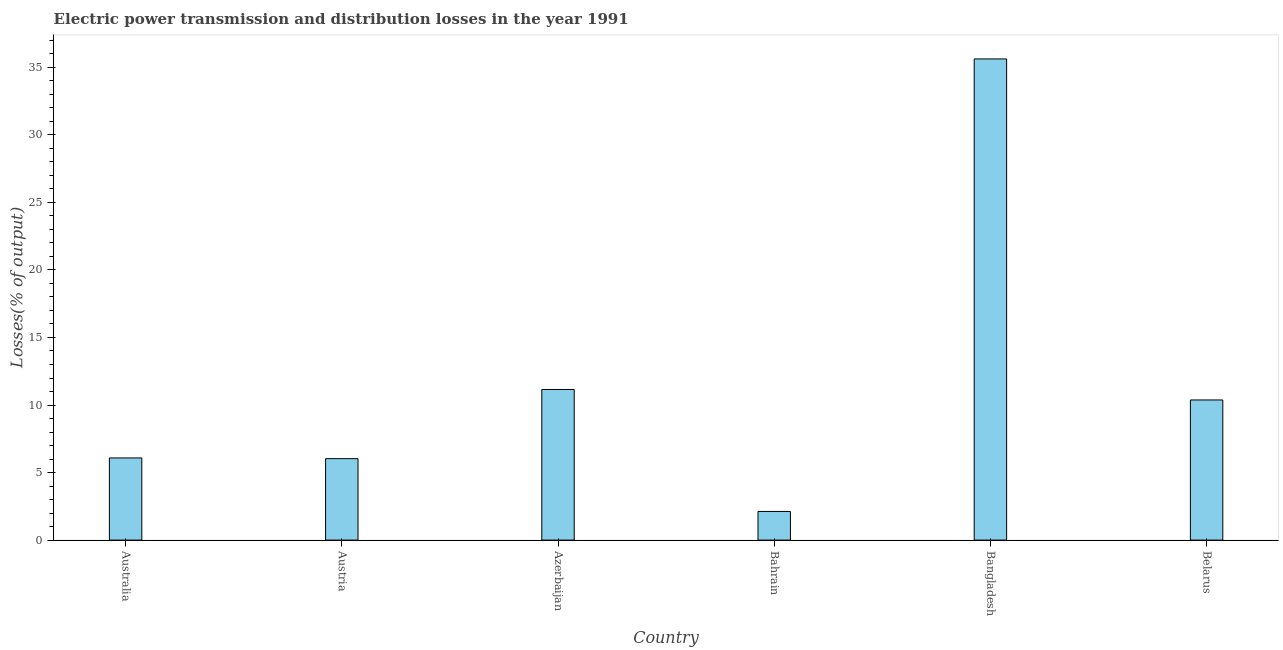What is the title of the graph?
Offer a terse response. Electric power transmission and distribution losses in the year 1991. What is the label or title of the Y-axis?
Ensure brevity in your answer.  Losses(% of output). What is the electric power transmission and distribution losses in Bahrain?
Make the answer very short. 2.12. Across all countries, what is the maximum electric power transmission and distribution losses?
Offer a very short reply. 35.62. Across all countries, what is the minimum electric power transmission and distribution losses?
Your answer should be compact. 2.12. In which country was the electric power transmission and distribution losses maximum?
Your answer should be very brief. Bangladesh. In which country was the electric power transmission and distribution losses minimum?
Provide a short and direct response. Bahrain. What is the sum of the electric power transmission and distribution losses?
Offer a terse response. 71.38. What is the difference between the electric power transmission and distribution losses in Austria and Bahrain?
Offer a terse response. 3.91. What is the average electric power transmission and distribution losses per country?
Your answer should be compact. 11.9. What is the median electric power transmission and distribution losses?
Provide a succinct answer. 8.23. In how many countries, is the electric power transmission and distribution losses greater than 28 %?
Your response must be concise. 1. What is the ratio of the electric power transmission and distribution losses in Austria to that in Bahrain?
Your answer should be very brief. 2.84. What is the difference between the highest and the second highest electric power transmission and distribution losses?
Keep it short and to the point. 24.47. Is the sum of the electric power transmission and distribution losses in Australia and Azerbaijan greater than the maximum electric power transmission and distribution losses across all countries?
Your answer should be compact. No. What is the difference between the highest and the lowest electric power transmission and distribution losses?
Your answer should be compact. 33.5. In how many countries, is the electric power transmission and distribution losses greater than the average electric power transmission and distribution losses taken over all countries?
Your response must be concise. 1. How many bars are there?
Make the answer very short. 6. How many countries are there in the graph?
Your response must be concise. 6. What is the difference between two consecutive major ticks on the Y-axis?
Provide a succinct answer. 5. Are the values on the major ticks of Y-axis written in scientific E-notation?
Ensure brevity in your answer.  No. What is the Losses(% of output) in Australia?
Provide a succinct answer. 6.08. What is the Losses(% of output) of Austria?
Make the answer very short. 6.03. What is the Losses(% of output) of Azerbaijan?
Ensure brevity in your answer.  11.15. What is the Losses(% of output) of Bahrain?
Your answer should be very brief. 2.12. What is the Losses(% of output) of Bangladesh?
Keep it short and to the point. 35.62. What is the Losses(% of output) in Belarus?
Keep it short and to the point. 10.38. What is the difference between the Losses(% of output) in Australia and Austria?
Your answer should be very brief. 0.05. What is the difference between the Losses(% of output) in Australia and Azerbaijan?
Your answer should be very brief. -5.07. What is the difference between the Losses(% of output) in Australia and Bahrain?
Give a very brief answer. 3.96. What is the difference between the Losses(% of output) in Australia and Bangladesh?
Your answer should be compact. -29.54. What is the difference between the Losses(% of output) in Australia and Belarus?
Keep it short and to the point. -4.29. What is the difference between the Losses(% of output) in Austria and Azerbaijan?
Make the answer very short. -5.12. What is the difference between the Losses(% of output) in Austria and Bahrain?
Provide a succinct answer. 3.91. What is the difference between the Losses(% of output) in Austria and Bangladesh?
Your answer should be very brief. -29.59. What is the difference between the Losses(% of output) in Austria and Belarus?
Your response must be concise. -4.35. What is the difference between the Losses(% of output) in Azerbaijan and Bahrain?
Your response must be concise. 9.03. What is the difference between the Losses(% of output) in Azerbaijan and Bangladesh?
Your answer should be compact. -24.47. What is the difference between the Losses(% of output) in Azerbaijan and Belarus?
Keep it short and to the point. 0.78. What is the difference between the Losses(% of output) in Bahrain and Bangladesh?
Your answer should be very brief. -33.5. What is the difference between the Losses(% of output) in Bahrain and Belarus?
Give a very brief answer. -8.25. What is the difference between the Losses(% of output) in Bangladesh and Belarus?
Your answer should be very brief. 25.25. What is the ratio of the Losses(% of output) in Australia to that in Azerbaijan?
Provide a succinct answer. 0.55. What is the ratio of the Losses(% of output) in Australia to that in Bahrain?
Provide a succinct answer. 2.87. What is the ratio of the Losses(% of output) in Australia to that in Bangladesh?
Provide a succinct answer. 0.17. What is the ratio of the Losses(% of output) in Australia to that in Belarus?
Your response must be concise. 0.59. What is the ratio of the Losses(% of output) in Austria to that in Azerbaijan?
Keep it short and to the point. 0.54. What is the ratio of the Losses(% of output) in Austria to that in Bahrain?
Keep it short and to the point. 2.84. What is the ratio of the Losses(% of output) in Austria to that in Bangladesh?
Ensure brevity in your answer.  0.17. What is the ratio of the Losses(% of output) in Austria to that in Belarus?
Your answer should be compact. 0.58. What is the ratio of the Losses(% of output) in Azerbaijan to that in Bahrain?
Give a very brief answer. 5.26. What is the ratio of the Losses(% of output) in Azerbaijan to that in Bangladesh?
Provide a succinct answer. 0.31. What is the ratio of the Losses(% of output) in Azerbaijan to that in Belarus?
Ensure brevity in your answer.  1.07. What is the ratio of the Losses(% of output) in Bahrain to that in Belarus?
Offer a very short reply. 0.2. What is the ratio of the Losses(% of output) in Bangladesh to that in Belarus?
Provide a succinct answer. 3.43. 